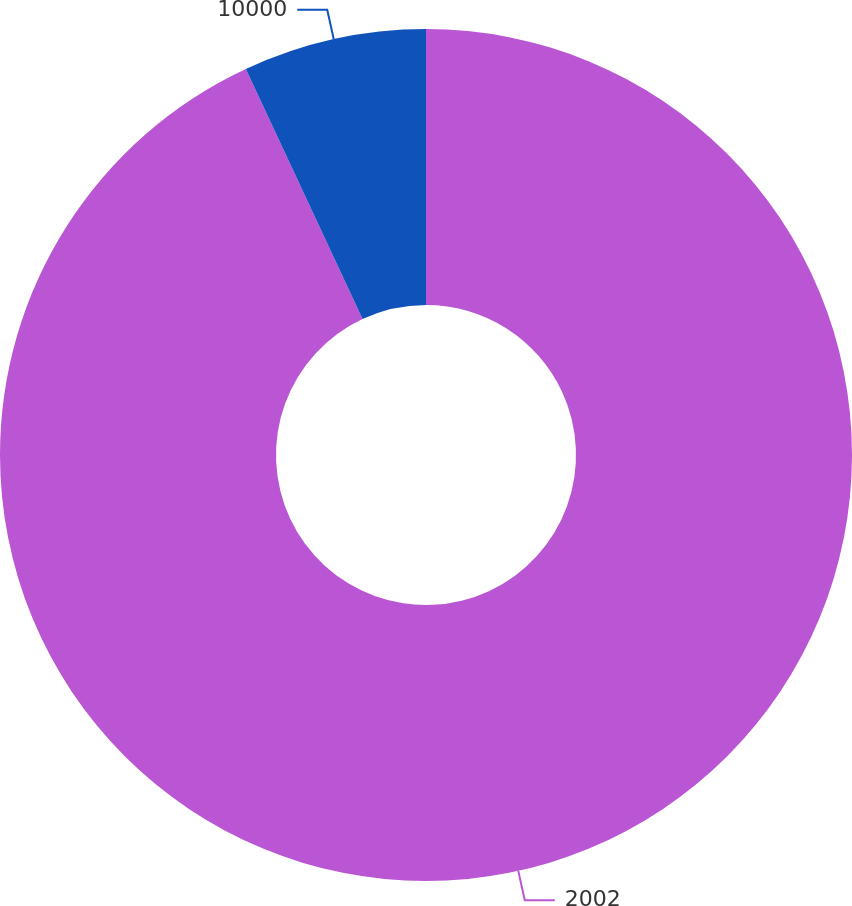Convert chart. <chart><loc_0><loc_0><loc_500><loc_500><pie_chart><fcel>2002<fcel>10000<nl><fcel>93.05%<fcel>6.95%<nl></chart> 